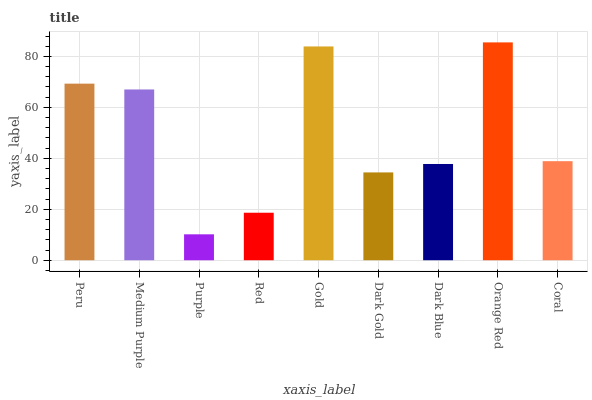Is Orange Red the maximum?
Answer yes or no. Yes. Is Medium Purple the minimum?
Answer yes or no. No. Is Medium Purple the maximum?
Answer yes or no. No. Is Peru greater than Medium Purple?
Answer yes or no. Yes. Is Medium Purple less than Peru?
Answer yes or no. Yes. Is Medium Purple greater than Peru?
Answer yes or no. No. Is Peru less than Medium Purple?
Answer yes or no. No. Is Coral the high median?
Answer yes or no. Yes. Is Coral the low median?
Answer yes or no. Yes. Is Dark Gold the high median?
Answer yes or no. No. Is Gold the low median?
Answer yes or no. No. 